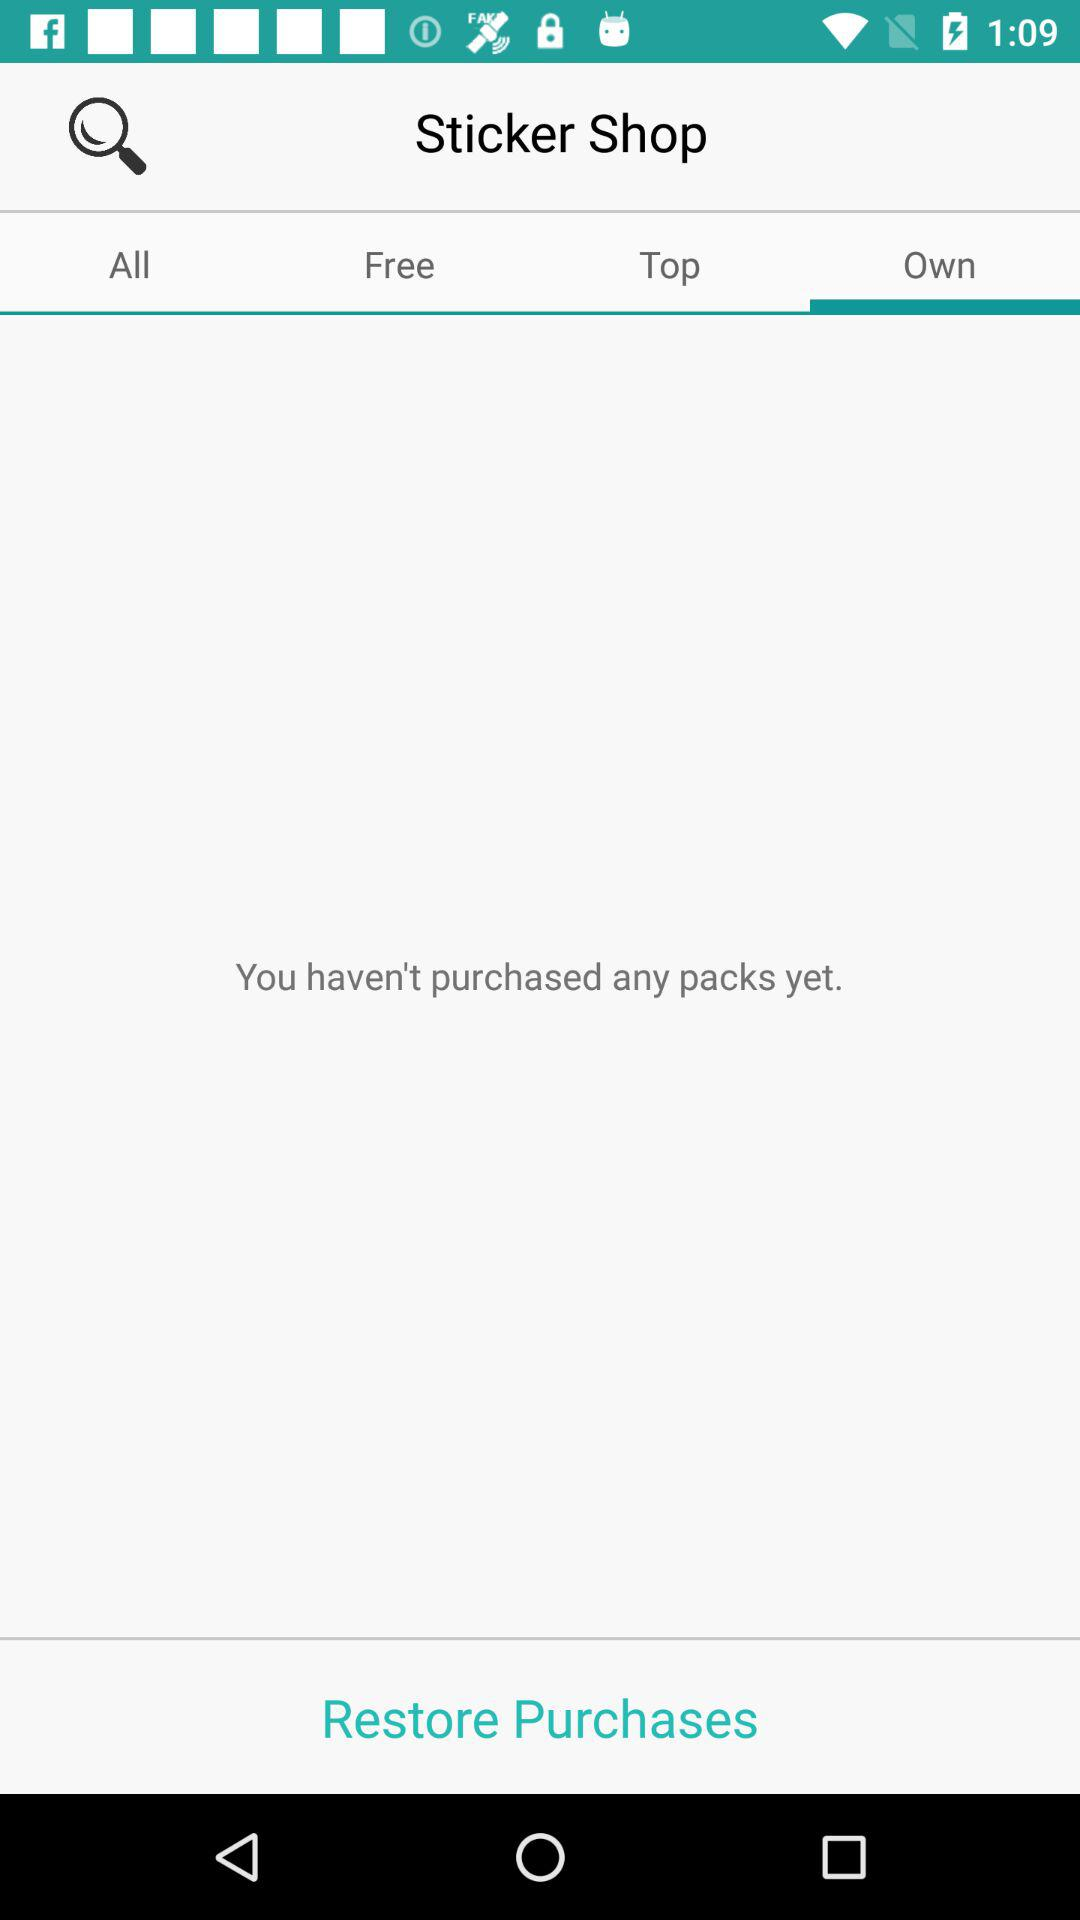What is the application name? The application name is "Sticker Shop". 